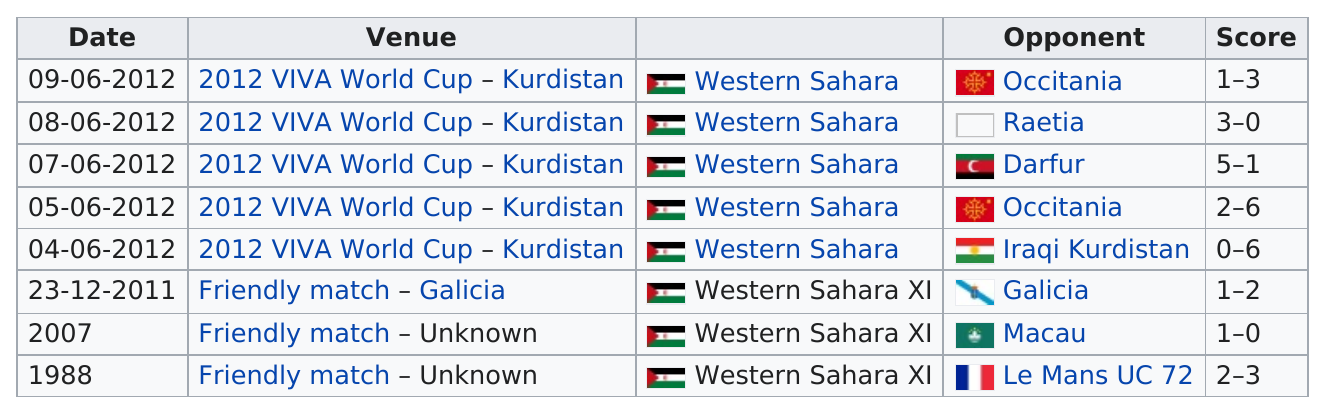Highlight a few significant elements in this photo. The total number of venues is either above or below 6, and it is currently below 6. The Sahrawi National Football Team has won a maximum of three international matches. The number of opponents is less than 10. The total combined score on September 6th, 2012, was 4. Western Sahara had the most winning scores compared to Macau in the given time period. 